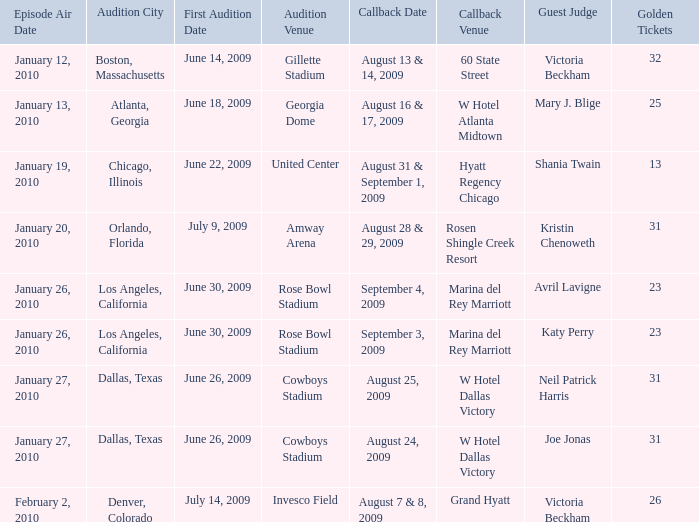Can you parse all the data within this table? {'header': ['Episode Air Date', 'Audition City', 'First Audition Date', 'Audition Venue', 'Callback Date', 'Callback Venue', 'Guest Judge', 'Golden Tickets'], 'rows': [['January 12, 2010', 'Boston, Massachusetts', 'June 14, 2009', 'Gillette Stadium', 'August 13 & 14, 2009', '60 State Street', 'Victoria Beckham', '32'], ['January 13, 2010', 'Atlanta, Georgia', 'June 18, 2009', 'Georgia Dome', 'August 16 & 17, 2009', 'W Hotel Atlanta Midtown', 'Mary J. Blige', '25'], ['January 19, 2010', 'Chicago, Illinois', 'June 22, 2009', 'United Center', 'August 31 & September 1, 2009', 'Hyatt Regency Chicago', 'Shania Twain', '13'], ['January 20, 2010', 'Orlando, Florida', 'July 9, 2009', 'Amway Arena', 'August 28 & 29, 2009', 'Rosen Shingle Creek Resort', 'Kristin Chenoweth', '31'], ['January 26, 2010', 'Los Angeles, California', 'June 30, 2009', 'Rose Bowl Stadium', 'September 4, 2009', 'Marina del Rey Marriott', 'Avril Lavigne', '23'], ['January 26, 2010', 'Los Angeles, California', 'June 30, 2009', 'Rose Bowl Stadium', 'September 3, 2009', 'Marina del Rey Marriott', 'Katy Perry', '23'], ['January 27, 2010', 'Dallas, Texas', 'June 26, 2009', 'Cowboys Stadium', 'August 25, 2009', 'W Hotel Dallas Victory', 'Neil Patrick Harris', '31'], ['January 27, 2010', 'Dallas, Texas', 'June 26, 2009', 'Cowboys Stadium', 'August 24, 2009', 'W Hotel Dallas Victory', 'Joe Jonas', '31'], ['February 2, 2010', 'Denver, Colorado', 'July 14, 2009', 'Invesco Field', 'August 7 & 8, 2009', 'Grand Hyatt', 'Victoria Beckham', '26']]} Where does the audition for hyatt regency chicago take place? Chicago, Illinois. 